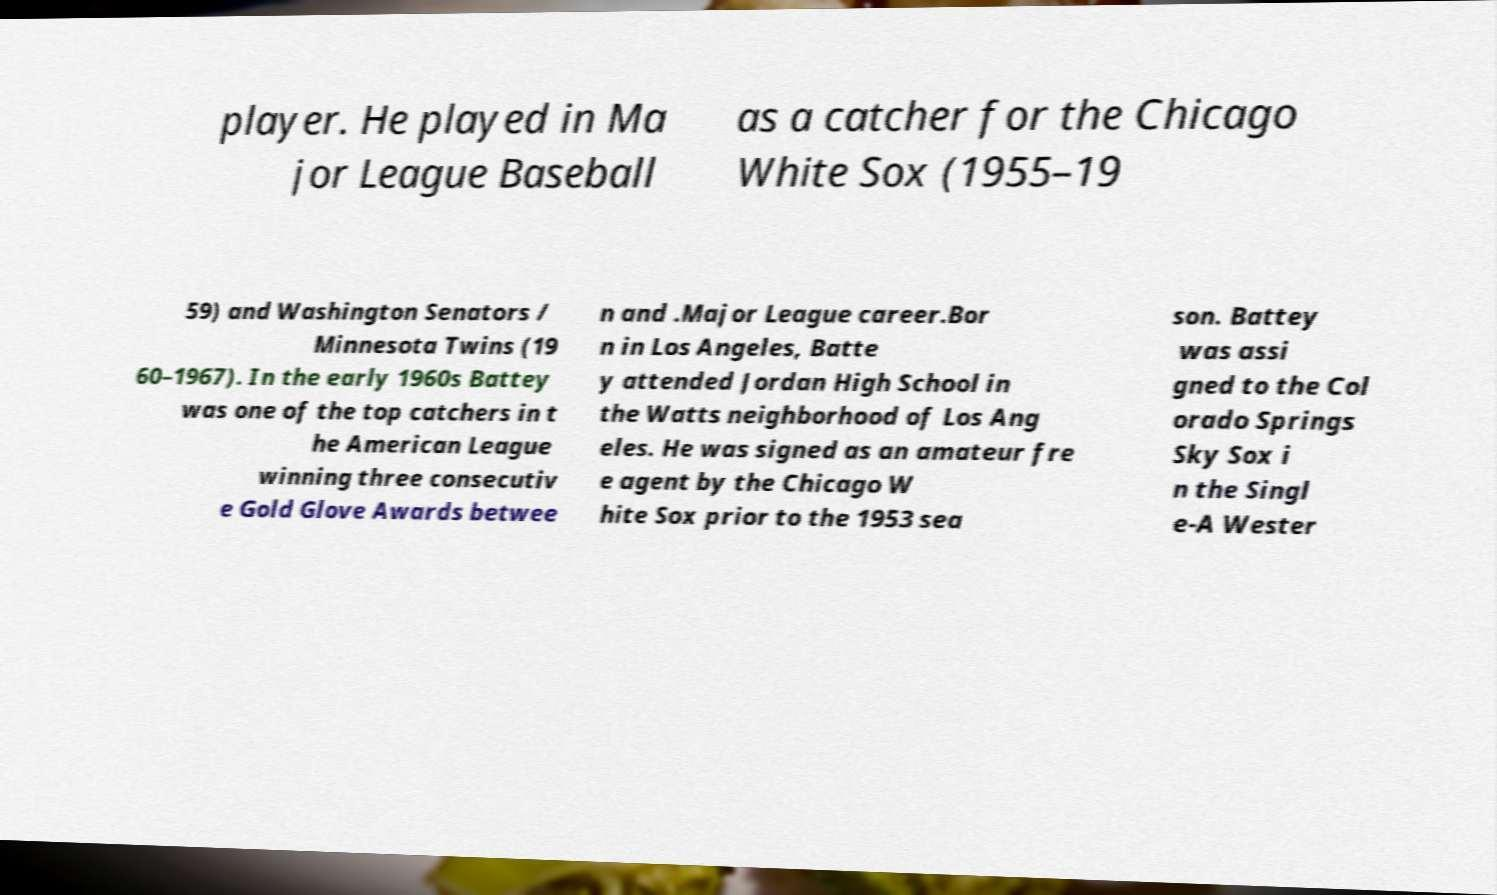Could you extract and type out the text from this image? player. He played in Ma jor League Baseball as a catcher for the Chicago White Sox (1955–19 59) and Washington Senators / Minnesota Twins (19 60–1967). In the early 1960s Battey was one of the top catchers in t he American League winning three consecutiv e Gold Glove Awards betwee n and .Major League career.Bor n in Los Angeles, Batte y attended Jordan High School in the Watts neighborhood of Los Ang eles. He was signed as an amateur fre e agent by the Chicago W hite Sox prior to the 1953 sea son. Battey was assi gned to the Col orado Springs Sky Sox i n the Singl e-A Wester 